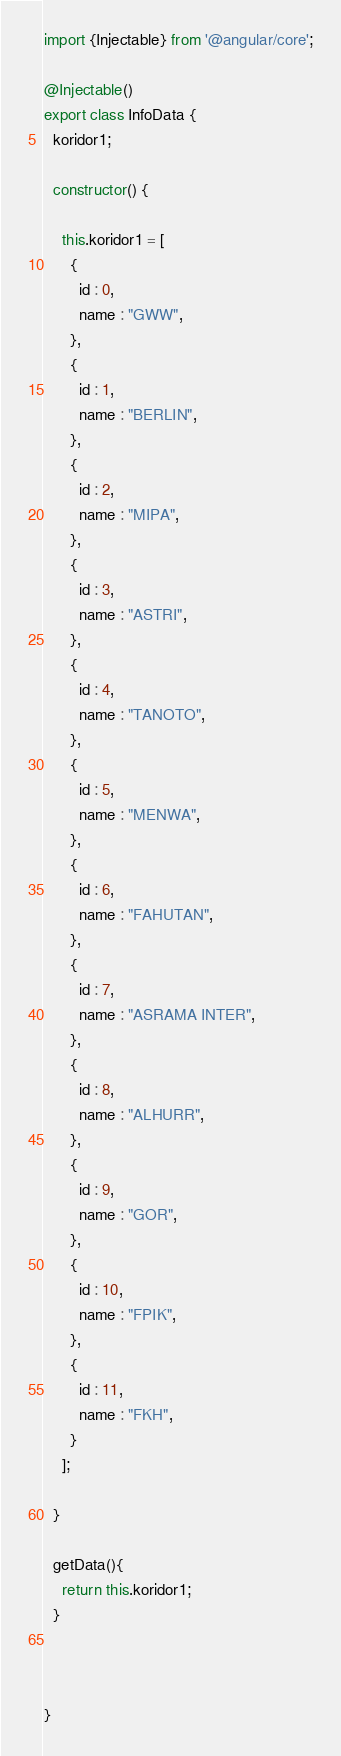<code> <loc_0><loc_0><loc_500><loc_500><_TypeScript_>import {Injectable} from '@angular/core';

@Injectable()
export class InfoData {
  koridor1;

  constructor() {

    this.koridor1 = [
      {
        id : 0,
        name : "GWW",
      },
      {
        id : 1,
        name : "BERLIN",
      },
      {
        id : 2,
        name : "MIPA",
      },
      {
        id : 3,
        name : "ASTRI",
      },
      {
        id : 4,
        name : "TANOTO",
      },
      {
        id : 5,
        name : "MENWA",
      },
      {
        id : 6,
        name : "FAHUTAN",
      },
      {
        id : 7,
        name : "ASRAMA INTER",
      },
      {
        id : 8,
        name : "ALHURR",
      },
      {
        id : 9,
        name : "GOR",
      },
      {
        id : 10,
        name : "FPIK",
      },
      {
        id : 11,
        name : "FKH",
      }
    ];

  }

  getData(){
    return this.koridor1;
  }



}
</code> 